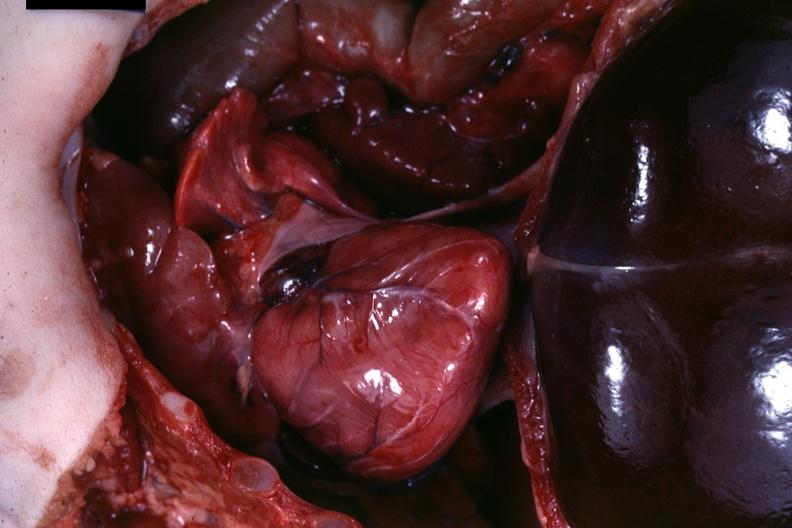what does this image show?
Answer the question using a single word or phrase. Opened body 